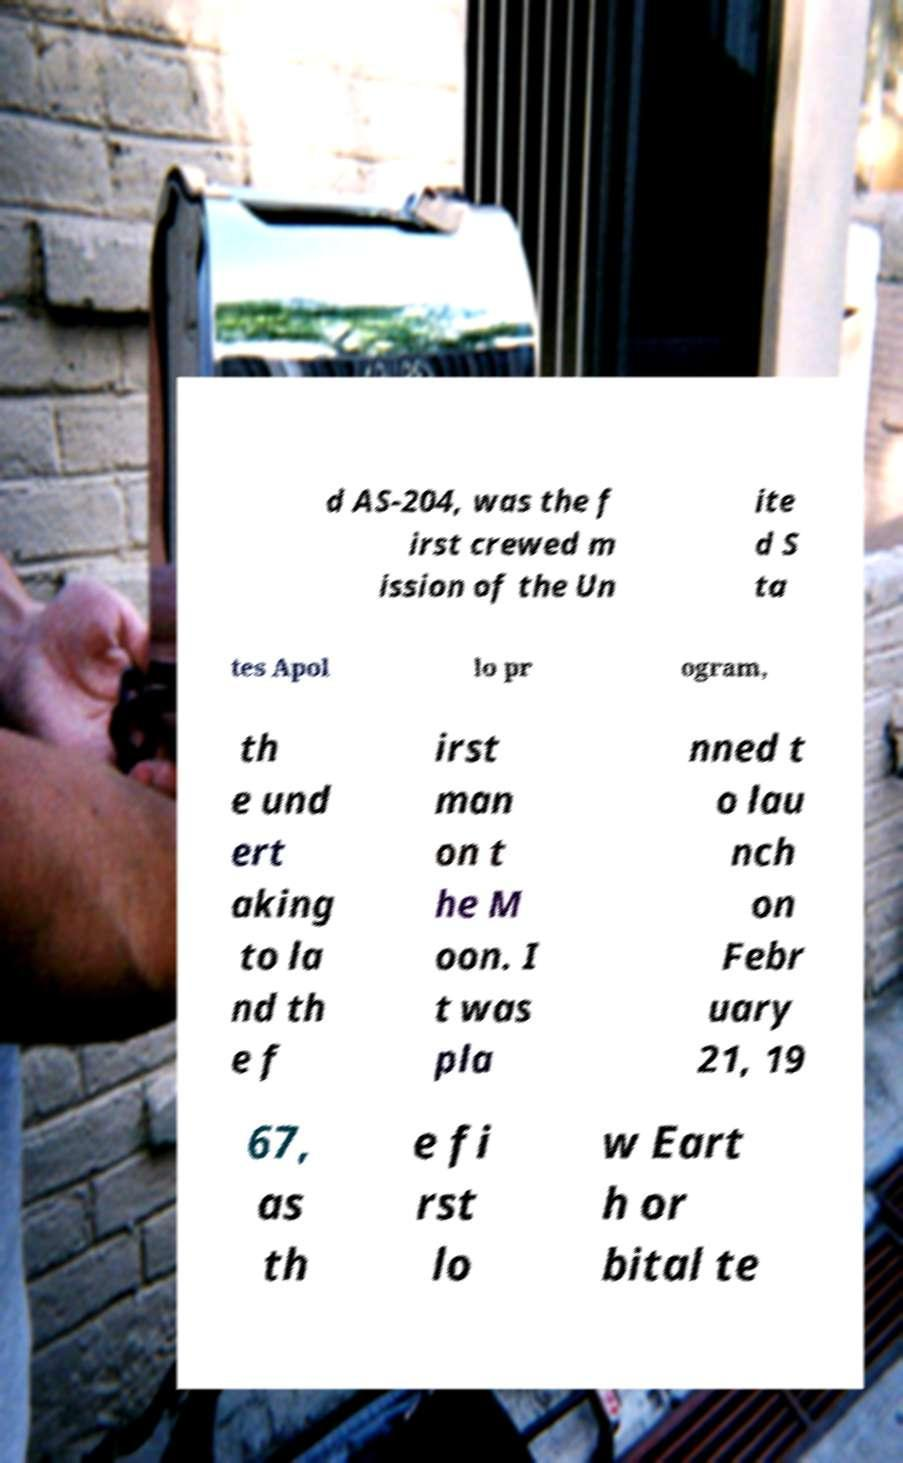Can you accurately transcribe the text from the provided image for me? d AS-204, was the f irst crewed m ission of the Un ite d S ta tes Apol lo pr ogram, th e und ert aking to la nd th e f irst man on t he M oon. I t was pla nned t o lau nch on Febr uary 21, 19 67, as th e fi rst lo w Eart h or bital te 